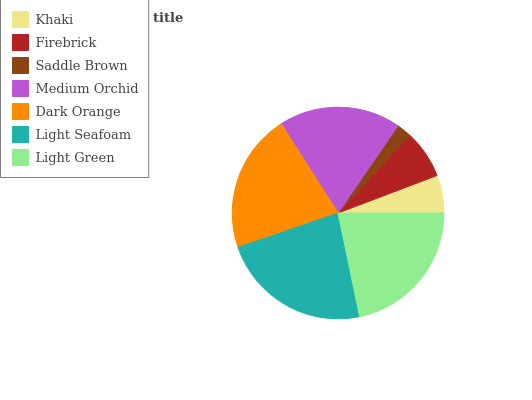Is Saddle Brown the minimum?
Answer yes or no. Yes. Is Light Seafoam the maximum?
Answer yes or no. Yes. Is Firebrick the minimum?
Answer yes or no. No. Is Firebrick the maximum?
Answer yes or no. No. Is Firebrick greater than Khaki?
Answer yes or no. Yes. Is Khaki less than Firebrick?
Answer yes or no. Yes. Is Khaki greater than Firebrick?
Answer yes or no. No. Is Firebrick less than Khaki?
Answer yes or no. No. Is Medium Orchid the high median?
Answer yes or no. Yes. Is Medium Orchid the low median?
Answer yes or no. Yes. Is Light Seafoam the high median?
Answer yes or no. No. Is Dark Orange the low median?
Answer yes or no. No. 